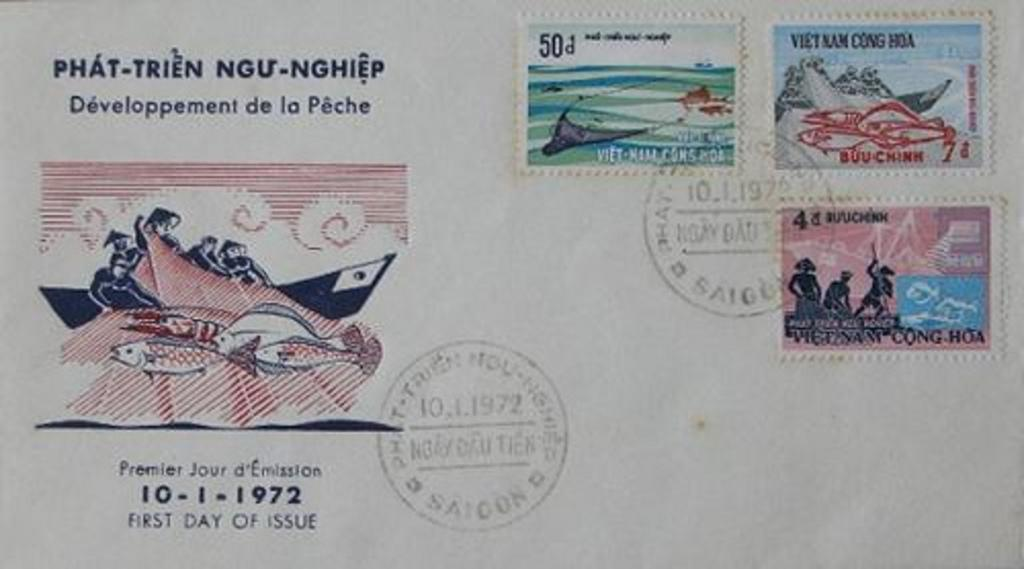<image>
Render a clear and concise summary of the photo. An envelope with three stamps and the date 10-1-1972 printed on it. 